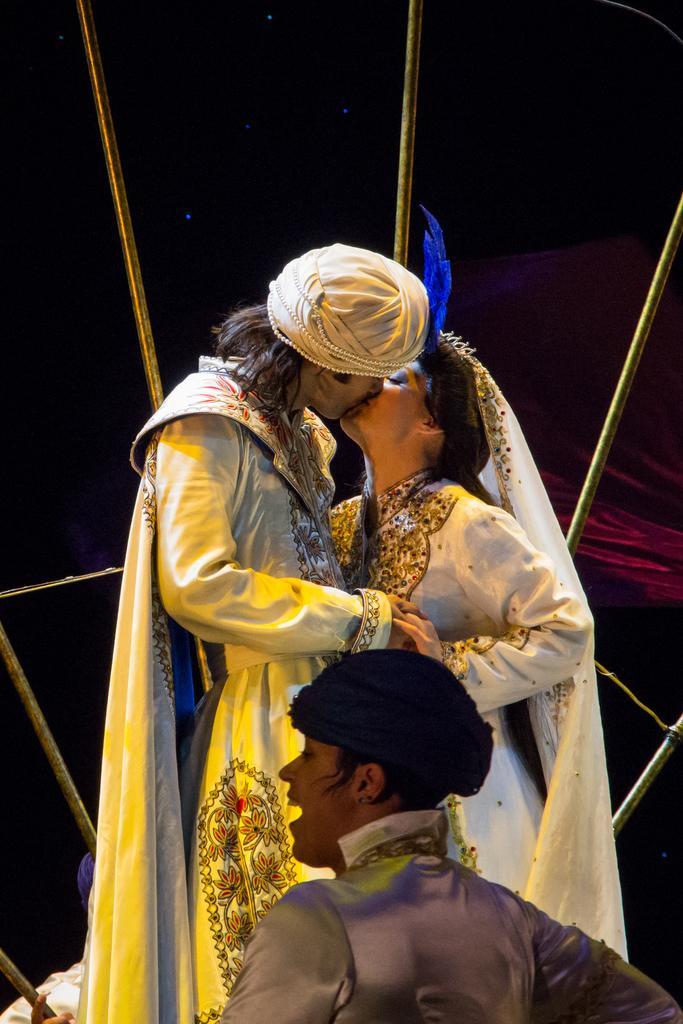Please provide a concise description of this image. In the foreground of this picture we can see a person seems to be standing. In the center we can see the two persons wearing white color dresses, standing, holding their hands and kissing each other. In the background we can see the metal rods and some other objects. 